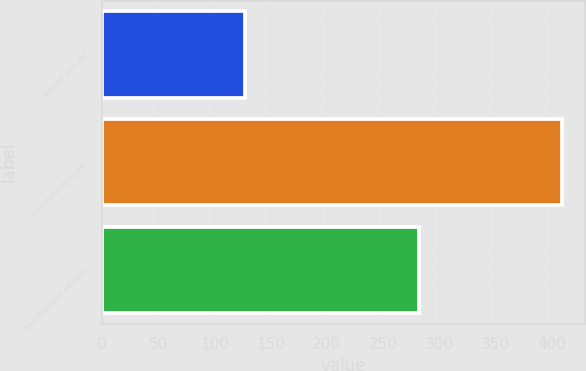Convert chart. <chart><loc_0><loc_0><loc_500><loc_500><bar_chart><fcel>Realized gain net<fcel>Unrealized (loss) gain<fcel>Total translated earnings<nl><fcel>127<fcel>409<fcel>282<nl></chart> 